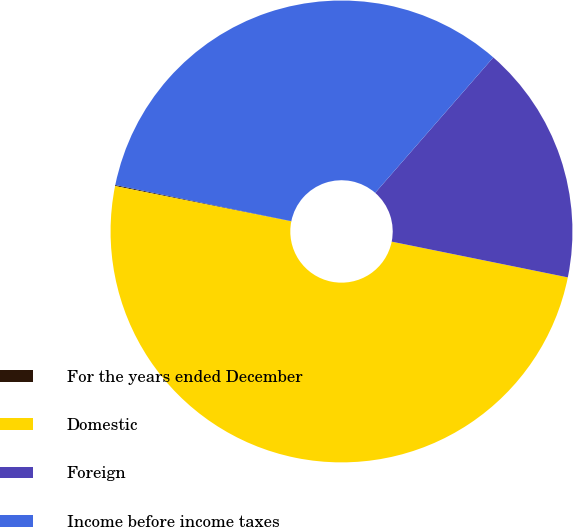Convert chart to OTSL. <chart><loc_0><loc_0><loc_500><loc_500><pie_chart><fcel>For the years ended December<fcel>Domestic<fcel>Foreign<fcel>Income before income taxes<nl><fcel>0.07%<fcel>49.96%<fcel>16.77%<fcel>33.19%<nl></chart> 